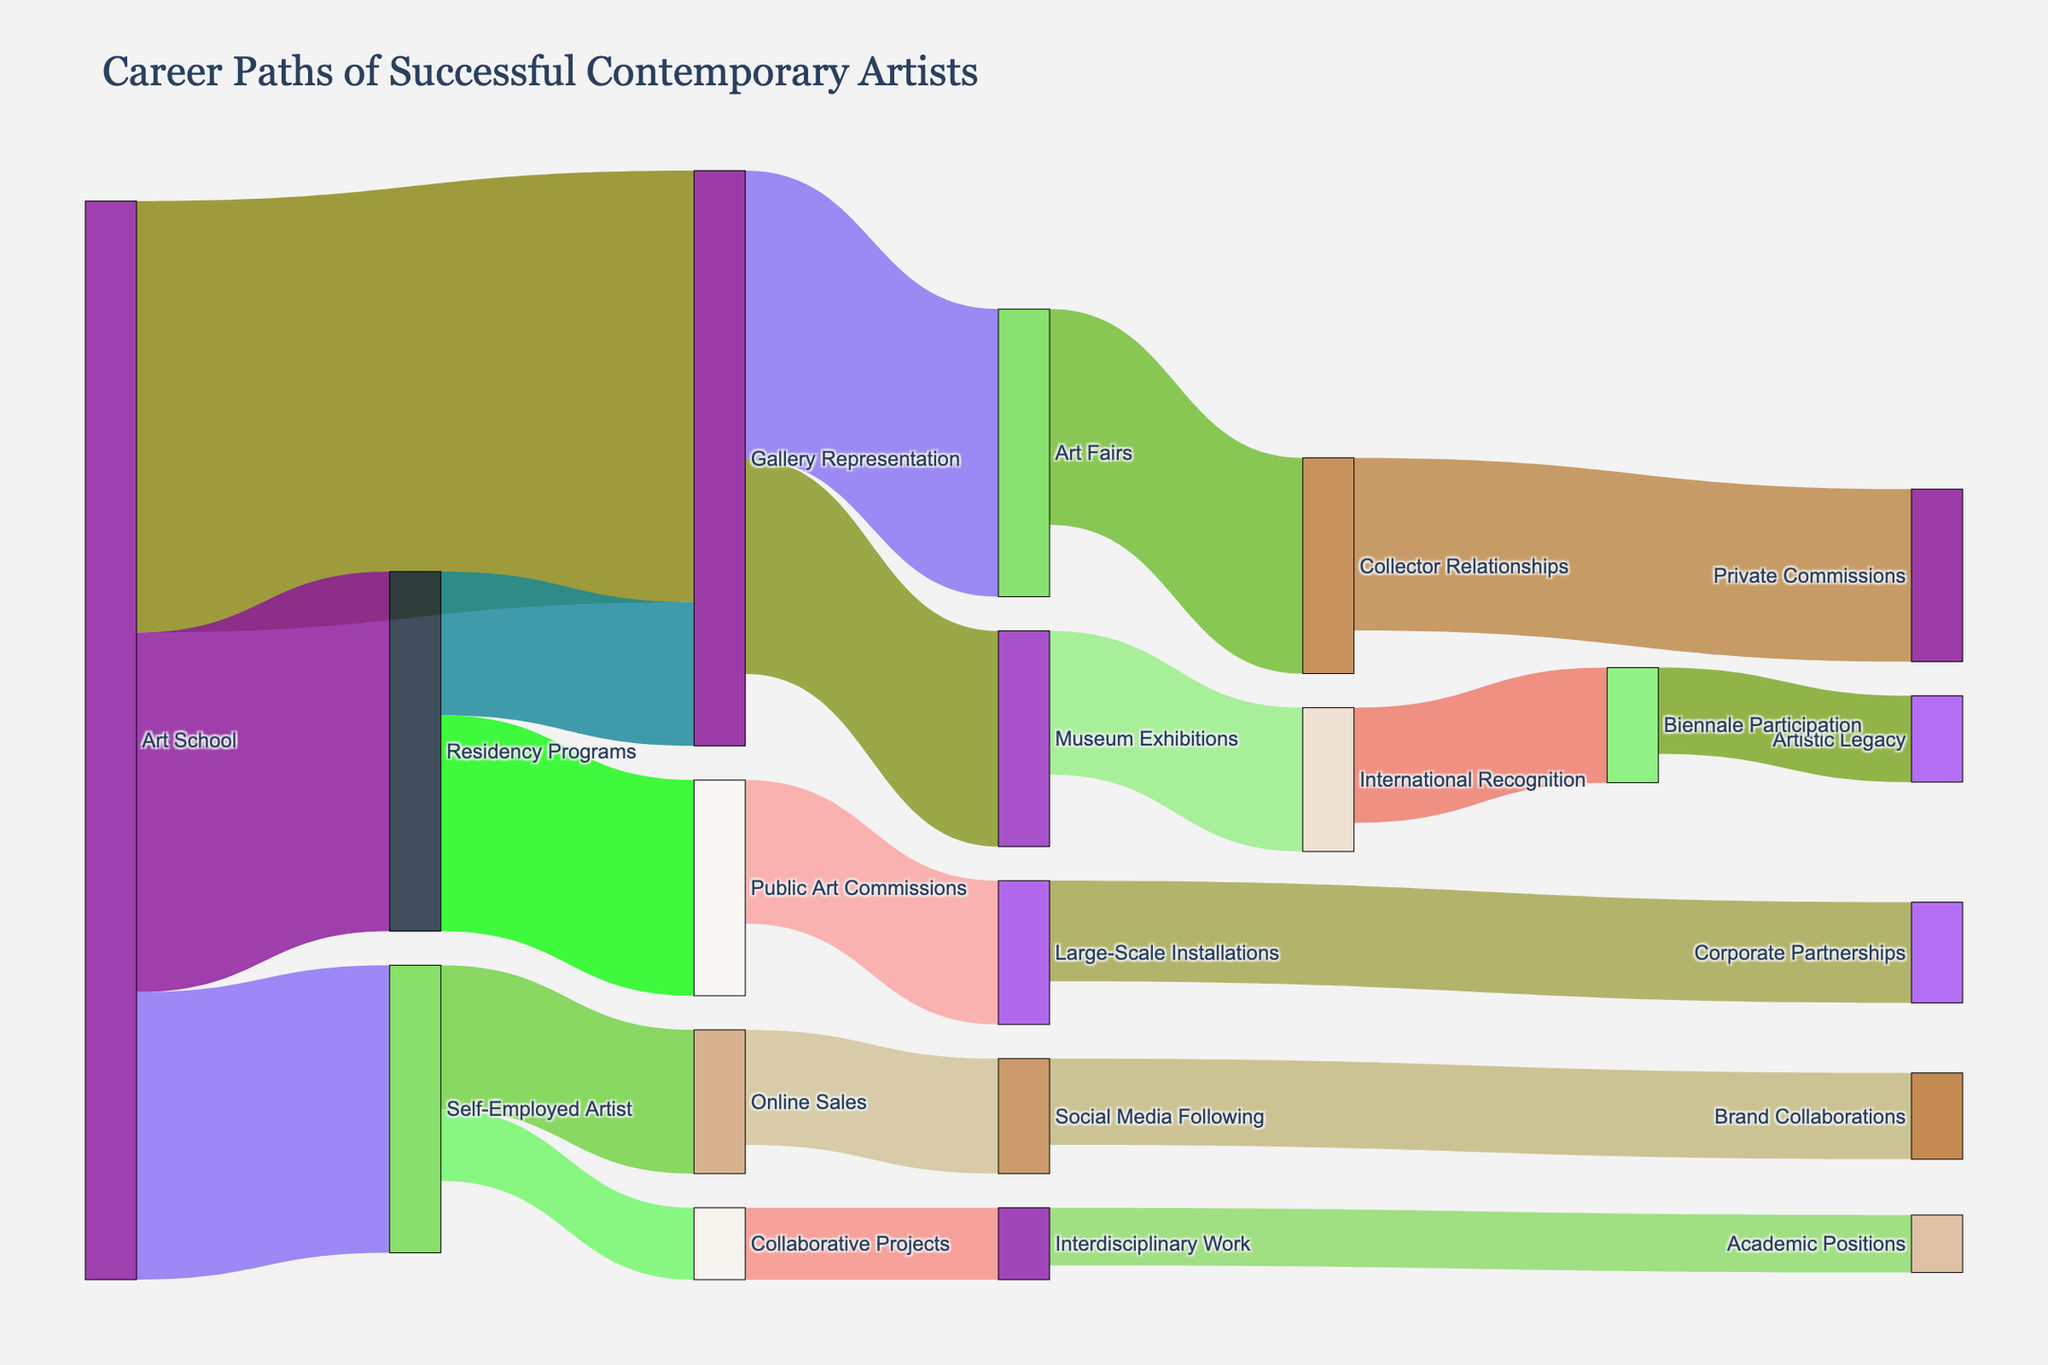What's the main title of the Sankey diagram? The main title is displayed at the top of the figure as a large text label. It summarizes the key focus of the diagram.
Answer: Career Paths of Successful Contemporary Artists How many nodes are there in the Sankey diagram? Count all the unique nodes (labels) that are either in the 'source' or 'target' list. There are 19 unique nodes.
Answer: 19 What's the initial step most artists start from according to the diagram? Look at the leftmost part of the diagram where the first nodes are located. 'Art School' is the node that appears first and has the highest number of outgoing links.
Answer: Art School Which career path has the largest value flowing from 'Art School'? Find the node connected to 'Art School' with the highest value. In this case, 'Gallery Representation' receives a flow value of 30 from 'Art School'.
Answer: Gallery Representation What is the total value of artists moving from 'Art School' to their next step? Sum all the values flowing out of 'Art School'. Values are 30, 25, and 20. So 30 + 25 + 20 = 75.
Answer: 75 Which target node has a value of 15 coming from 'Residency Programs'? Look for the node that 'Residency Programs' connects to with a value of 15. 'Public Art Commissions' receives a flow of 15 from 'Residency Programs'.
Answer: Public Art Commissions How many paths connect to 'Gallery Representation'? Count the number of links leading to and from 'Gallery Representation'. Two paths lead to ('Art School', 'Residency Programs') and two paths lead from ('Museum Exhibitions', 'Art Fairs').
Answer: 4 What value moves from 'Museum Exhibitions' to 'International Recognition'? Identify the value indicated on the link between 'Museum Exhibitions' and 'International Recognition'. The value is 10.
Answer: 10 Which node has the largest number of incoming paths? Determine which node has the greatest number of incoming links. 'Gallery Representation' has two incoming paths from 'Art School' (30) and 'Residency Programs' (10).
Answer: Gallery Representation What is the final step for paths originating at 'Art Fairs'? Look at the nodes connected directly from 'Art Fairs' and then trace their subsequent connections to find the final steps. 'Art Fairs' leads to 'Collector Relationships' (15), which then leads to 'Private Commissions' (12).
Answer: Private Commissions 